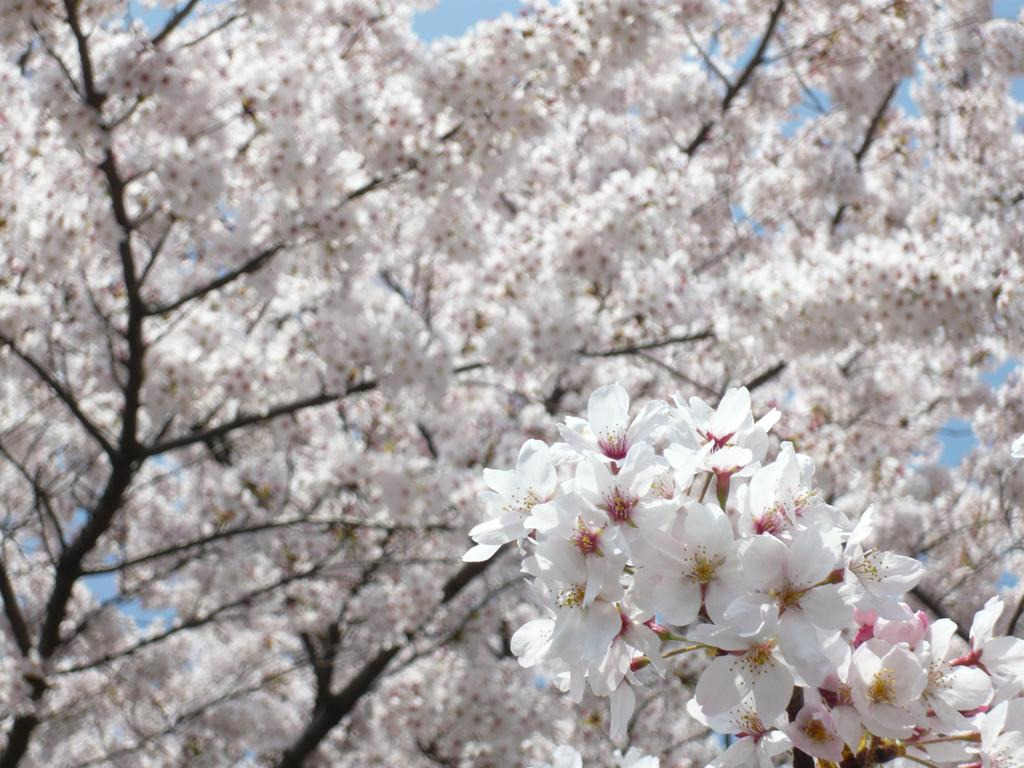What type of plant can be seen in the image? There is a tree in the image. What additional feature can be observed on the tree? The tree has flowers. What color is the sky in the image? The sky is blue in the image. What is the opinion of the tramp about the toad in the image? There is no tramp or toad present in the image, so it is not possible to determine their opinions. 